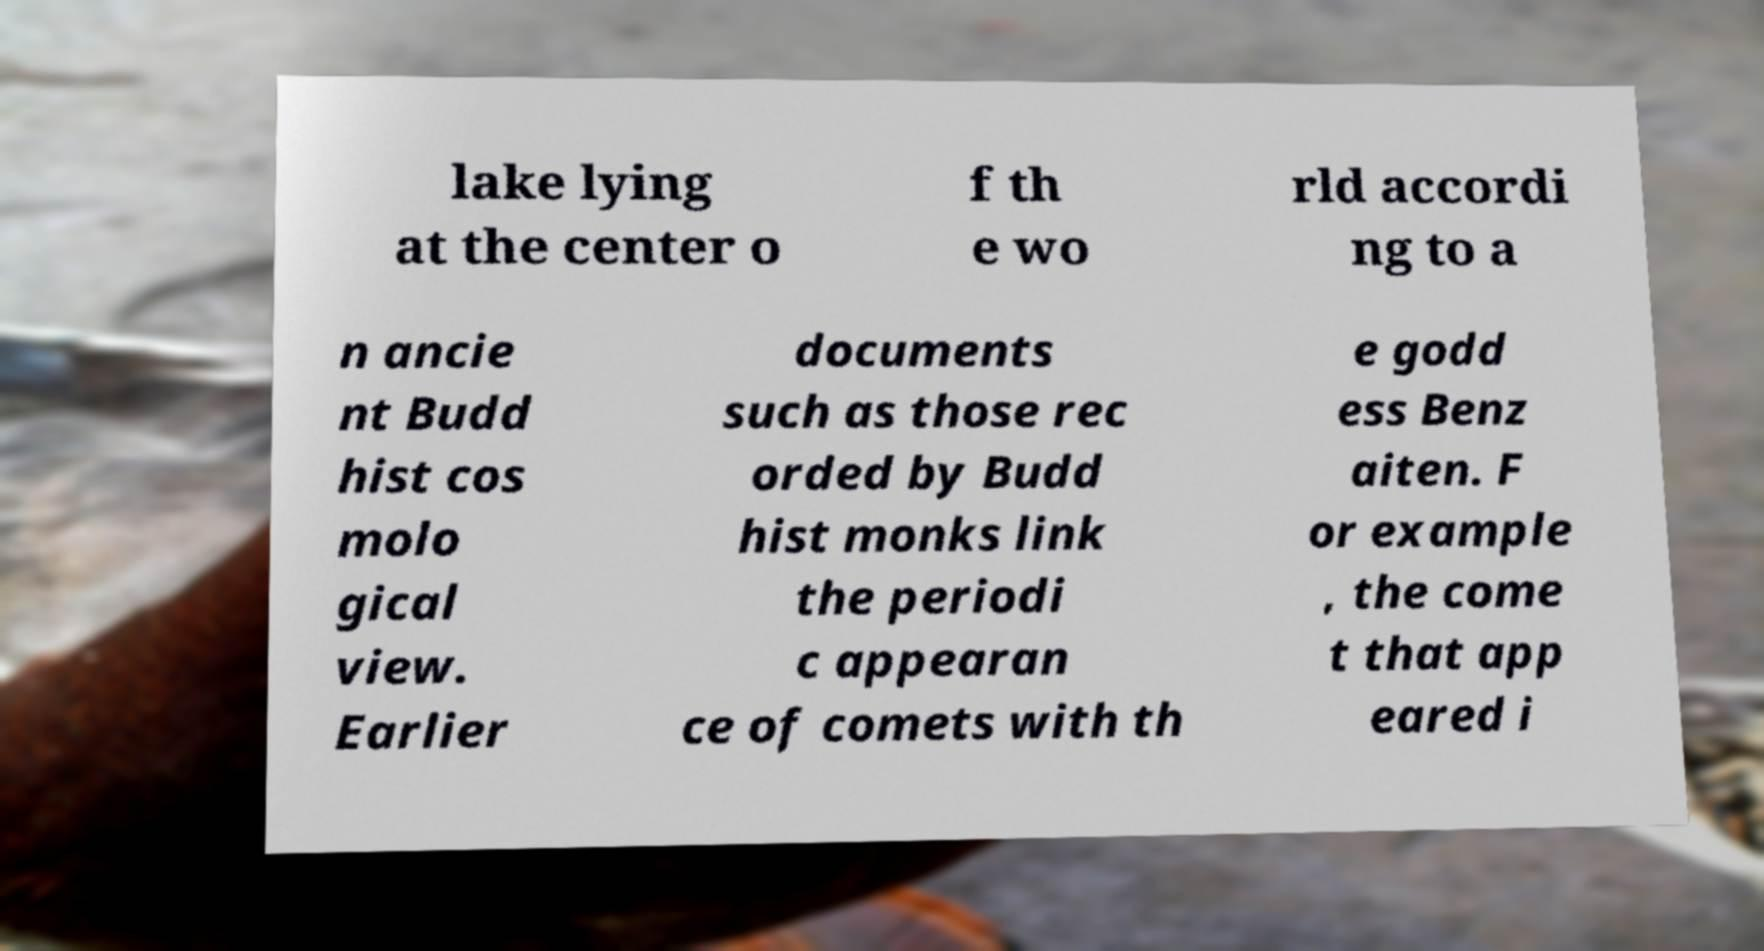Can you accurately transcribe the text from the provided image for me? lake lying at the center o f th e wo rld accordi ng to a n ancie nt Budd hist cos molo gical view. Earlier documents such as those rec orded by Budd hist monks link the periodi c appearan ce of comets with th e godd ess Benz aiten. F or example , the come t that app eared i 